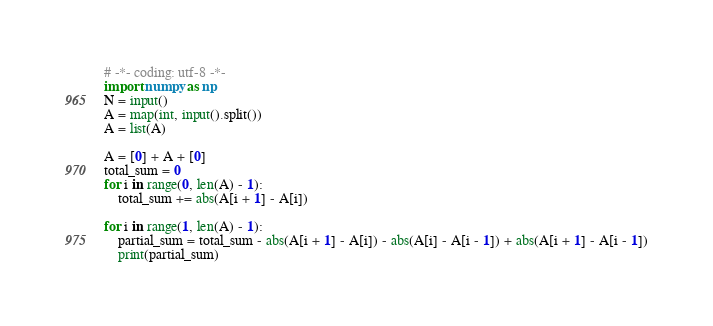<code> <loc_0><loc_0><loc_500><loc_500><_Python_># -*- coding: utf-8 -*-
import numpy as np
N = input()
A = map(int, input().split())
A = list(A)

A = [0] + A + [0]
total_sum = 0
for i in range(0, len(A) - 1):
    total_sum += abs(A[i + 1] - A[i])

for i in range(1, len(A) - 1):
    partial_sum = total_sum - abs(A[i + 1] - A[i]) - abs(A[i] - A[i - 1]) + abs(A[i + 1] - A[i - 1])
    print(partial_sum)
</code> 